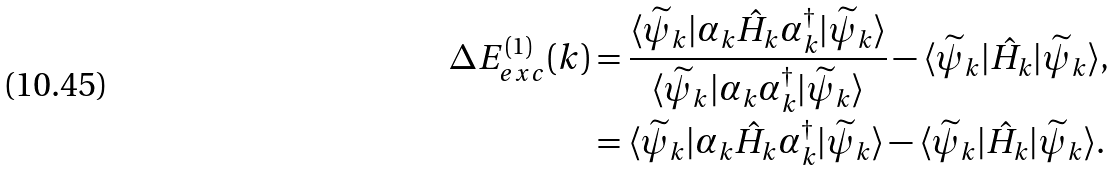<formula> <loc_0><loc_0><loc_500><loc_500>\Delta E _ { e x c } ^ { ( 1 ) } ( { k } ) & = \frac { \langle \widetilde { \psi } _ { k } | \alpha _ { k } \hat { H } _ { k } \alpha _ { k } ^ { \dagger } | \widetilde { \psi } _ { k } \rangle } { \langle \widetilde { \psi } _ { k } | \alpha _ { k } \alpha _ { k } ^ { \dagger } | \widetilde { \psi } _ { k } \rangle } - \langle \widetilde { \psi } _ { k } | \hat { H } _ { k } | \widetilde { \psi } _ { k } \rangle , \\ & = \langle \widetilde { \psi } _ { k } | \alpha _ { k } \hat { H } _ { k } \alpha _ { k } ^ { \dagger } | \widetilde { \psi } _ { k } \rangle - \langle \widetilde { \psi } _ { k } | \hat { H } _ { k } | \widetilde { \psi } _ { k } \rangle .</formula> 